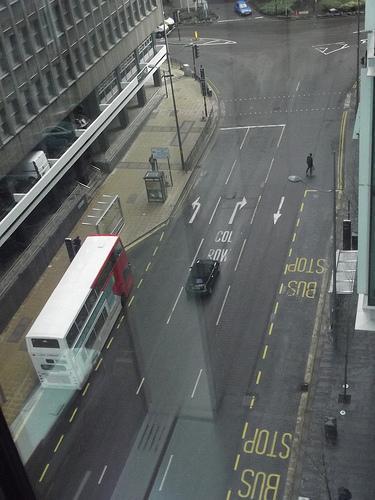How many blue pickup trucks are on the street?
Give a very brief answer. 0. 